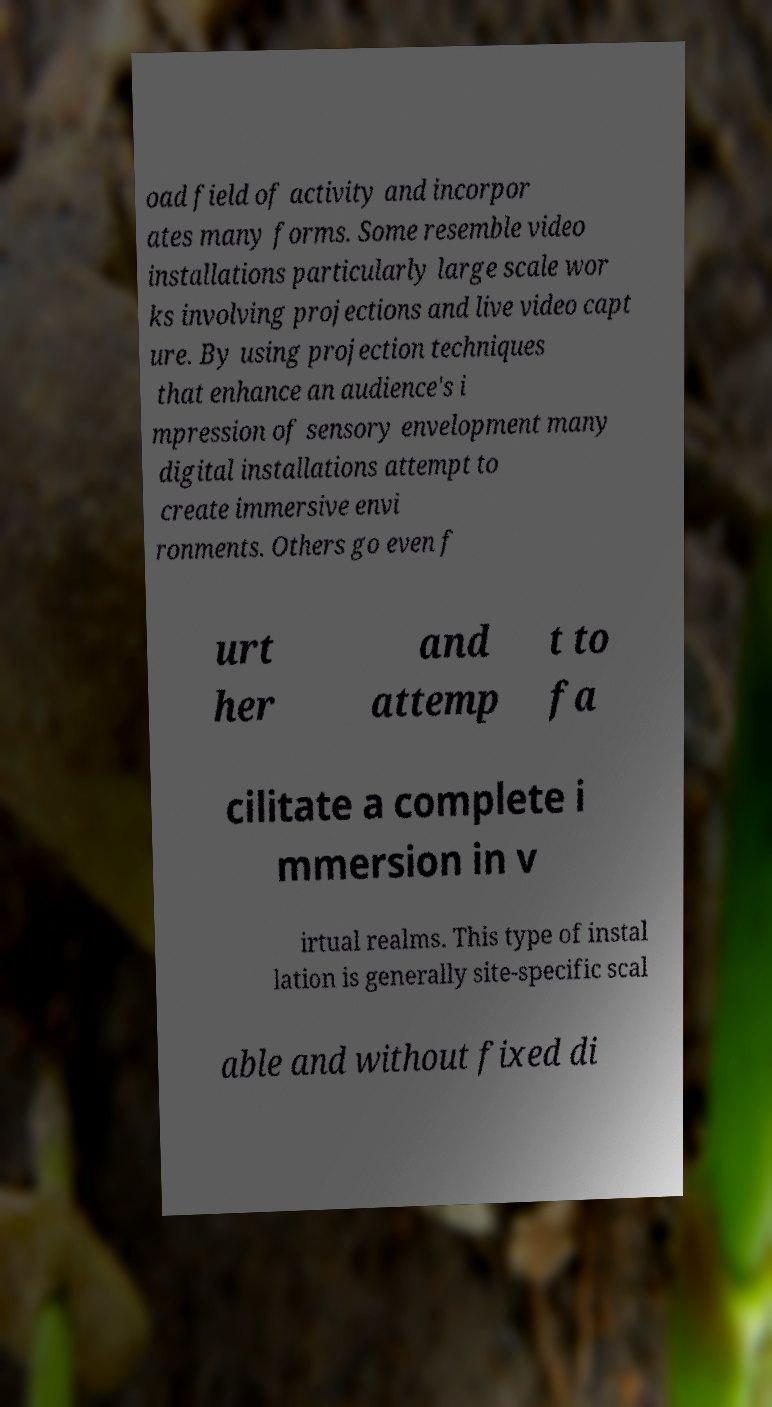Can you accurately transcribe the text from the provided image for me? oad field of activity and incorpor ates many forms. Some resemble video installations particularly large scale wor ks involving projections and live video capt ure. By using projection techniques that enhance an audience's i mpression of sensory envelopment many digital installations attempt to create immersive envi ronments. Others go even f urt her and attemp t to fa cilitate a complete i mmersion in v irtual realms. This type of instal lation is generally site-specific scal able and without fixed di 